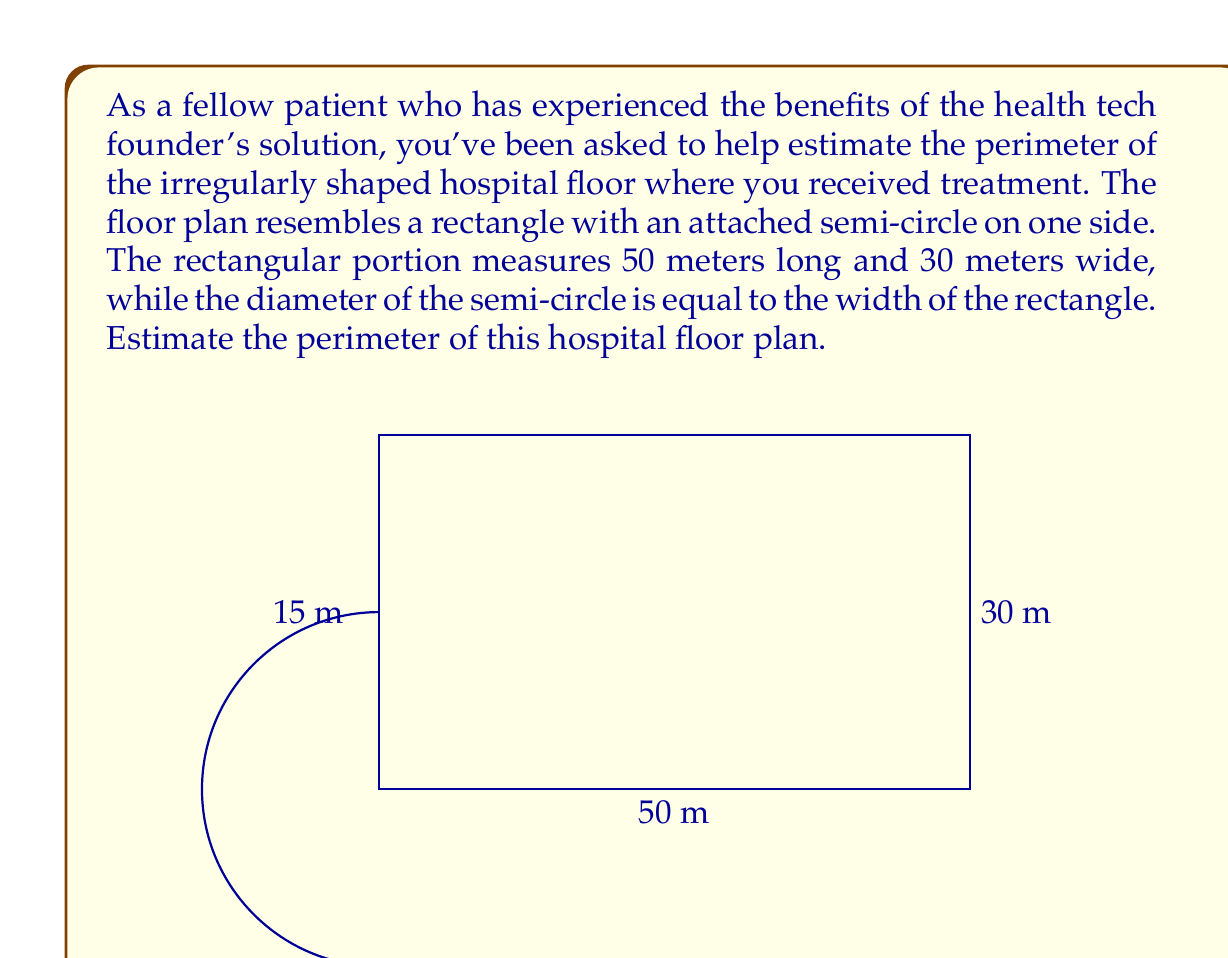Can you solve this math problem? Let's approach this step-by-step:

1) The floor plan consists of a rectangle and a semi-circle.

2) For the rectangle:
   - Length = 50 meters
   - Width = 30 meters
   - Perimeter of rectangle = $2(length + width)$
   - $P_{rectangle} = 2(50 + 30) = 2(80) = 160$ meters

3) For the semi-circle:
   - Diameter = width of rectangle = 30 meters
   - Radius = 15 meters
   - Circumference of a full circle = $2\pi r$
   - Perimeter of semi-circle = $\frac{1}{2}(2\pi r) = \pi r$
   - $P_{semi-circle} = \pi(15) \approx 47.12$ meters

4) However, we need to subtract the diameter of the semi-circle from the rectangle's perimeter as it's replaced by the curved part:
   - Length to subtract = 30 meters

5) Total perimeter:
   $$P_{total} = P_{rectangle} - 30 + P_{semi-circle}$$
   $$P_{total} = 160 - 30 + 47.12 = 177.12\text{ meters}$$

6) Rounding to the nearest meter:
   $$P_{total} \approx 177\text{ meters}$$
Answer: The estimated perimeter of the irregularly shaped hospital floor plan is approximately 177 meters. 